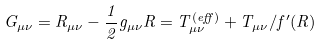<formula> <loc_0><loc_0><loc_500><loc_500>G _ { \mu \nu } = R _ { \mu \nu } - \frac { 1 } { 2 } g _ { \mu \nu } R = T ^ { ( e f f ) } _ { \mu \nu } + T _ { \mu \nu } / f ^ { \prime } ( R )</formula> 